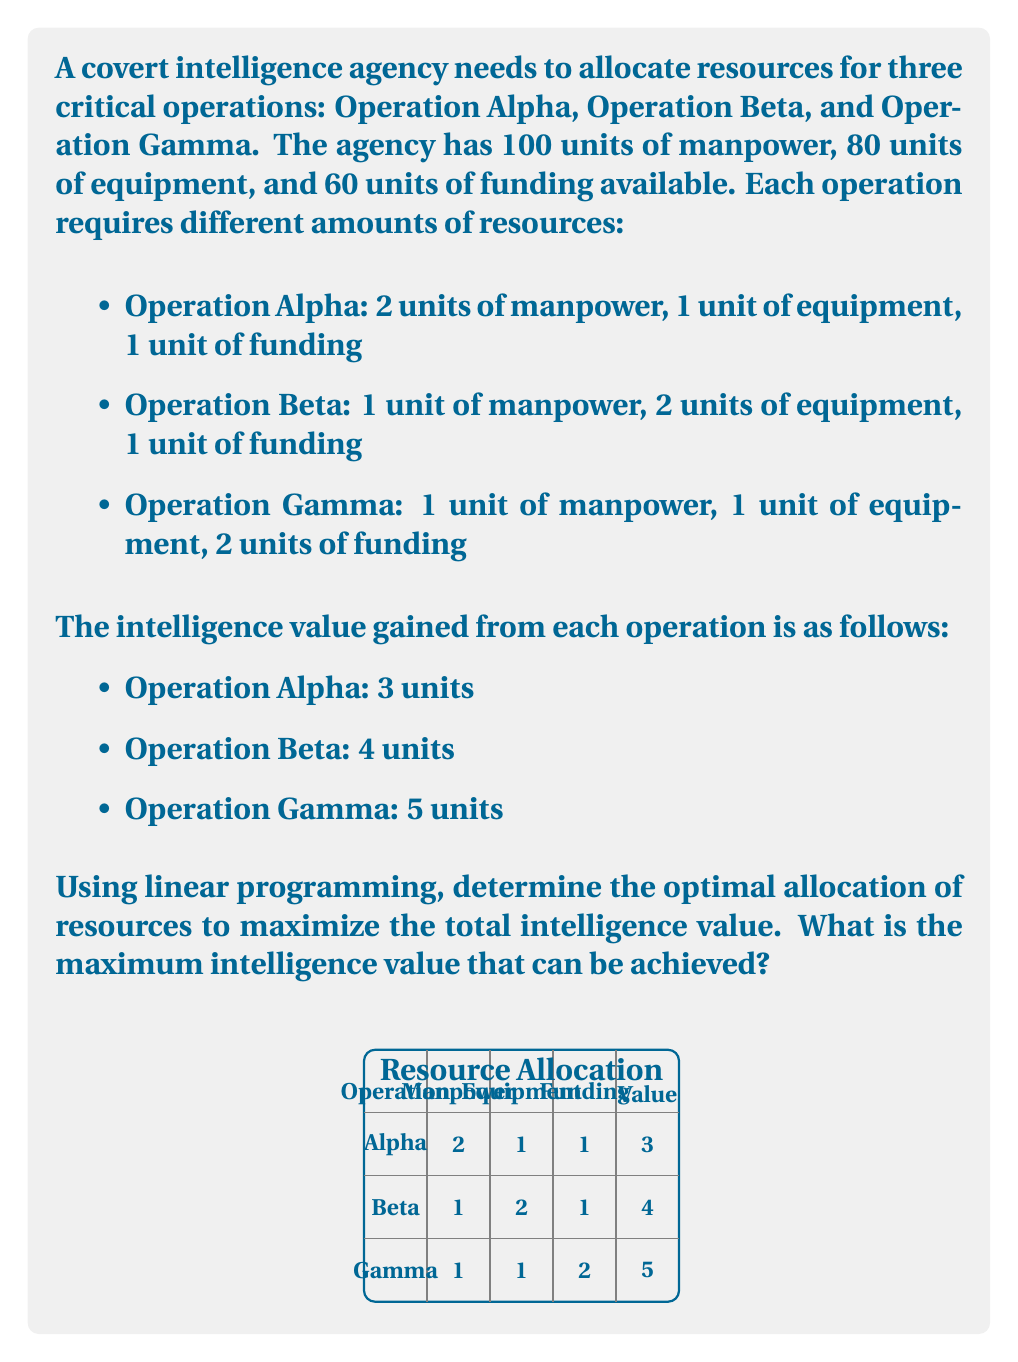Could you help me with this problem? To solve this linear programming problem, we'll follow these steps:

1) Define variables:
   Let $x$, $y$, and $z$ be the number of times Operations Alpha, Beta, and Gamma are conducted, respectively.

2) Set up the objective function:
   Maximize $Z = 3x + 4y + 5z$

3) Define constraints:
   Manpower: $2x + y + z \leq 100$
   Equipment: $x + 2y + z \leq 80$
   Funding: $x + y + 2z \leq 60$
   Non-negativity: $x, y, z \geq 0$

4) Solve using the simplex method or a linear programming solver. Here, we'll use the graphical method for visualization.

5) The feasible region is bounded by the constraints. The optimal solution will be at one of the corner points of this region.

6) Calculate the corner points by solving the equations in pairs:
   (0, 40, 0), (0, 0, 30), (50, 0, 0), (20, 30, 0), (10, 0, 25), (0, 20, 20)

7) Evaluate the objective function at each corner point:
   (0, 40, 0): Z = 160
   (0, 0, 30): Z = 150
   (50, 0, 0): Z = 150
   (20, 30, 0): Z = 180
   (10, 0, 25): Z = 155
   (0, 20, 20): Z = 180

8) The maximum value of Z is 180, which occurs at two points: (20, 30, 0) and (0, 20, 20).

Therefore, the maximum intelligence value that can be achieved is 180 units. This can be done by either:
a) Conducting Operation Alpha 20 times and Operation Beta 30 times, or
b) Conducting Operation Beta 20 times and Operation Gamma 20 times.
Answer: 180 intelligence units 